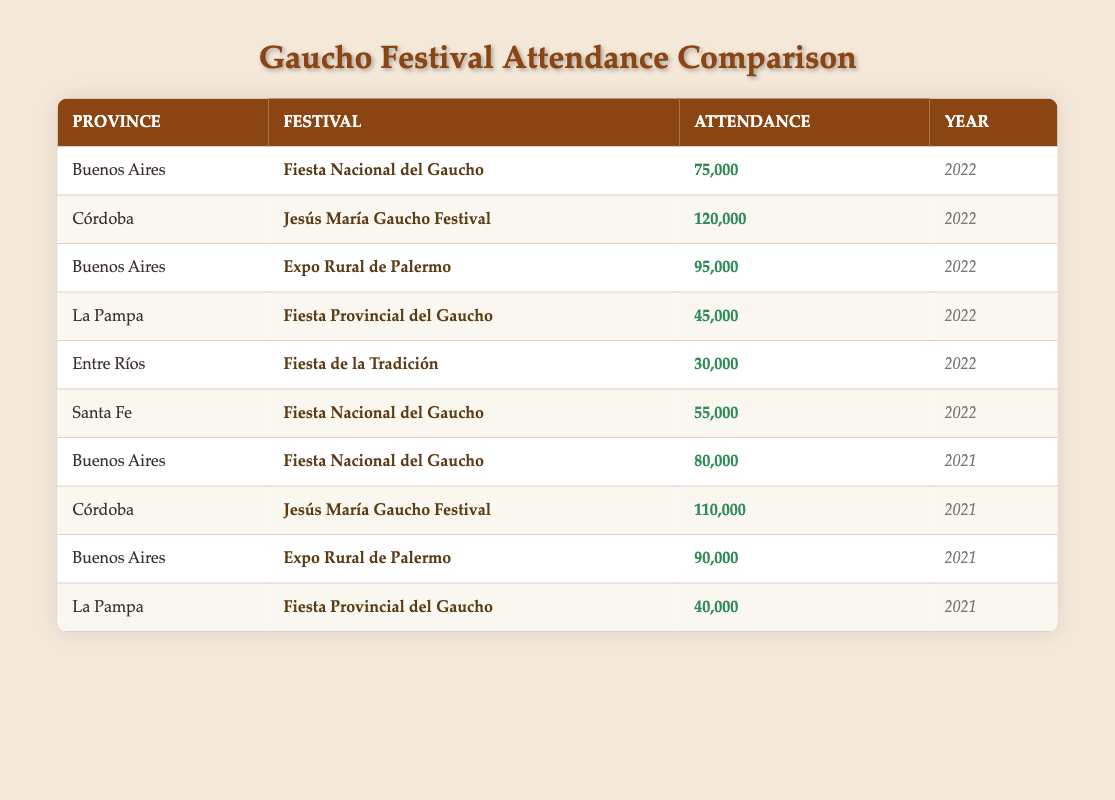What was the highest attendance at a gaucho festival in 2022? In the table, I look for the highest attendance value in the year 2022. The highest attendance is 120,000, which corresponds to the Córdoba province's Jesús María Gaucho Festival.
Answer: 120,000 Which province had the lowest attendance in 2022? By reviewing the attendance data for 2022, I find that Entre Ríos had the lowest attendance at 30,000 during the Fiesta de la Tradición.
Answer: Entre Ríos What is the total attendance for Buenos Aires festivals in 2021? I look for the attendance records for Buenos Aires in 2021, which are 80,000 for the Fiesta Nacional del Gaucho and 90,000 for Expo Rural de Palermo. Summing these values gives 80,000 + 90,000 = 170,000.
Answer: 170,000 Did La Pampa have a gaucho festival attendance higher than Santa Fe in 2022? Checking the attendance of La Pampa, which was 45,000, and Santa Fe, which was 55,000, reveals that La Pampa's attendance is lower than Santa Fe's. Therefore, the answer is no.
Answer: No What was the average attendance for the Jesús María Gaucho Festival over 2021 and 2022? The attendance for the Jesús María Gaucho Festival in 2021 is 110,000, and in 2022, it is 120,000. To find the average: (110,000 + 120,000) / 2 = 230,000 / 2 = 115,000.
Answer: 115,000 How many more attendees did the Expo Rural de Palermo have compared to the Fiesta Provincial del Gaucho in 2022? The Expo Rural de Palermo had an attendance of 95,000 in 2022, while the Fiesta Provincial del Gaucho in La Pampa had 45,000. The difference is 95,000 - 45,000 = 50,000.
Answer: 50,000 Is Santa Fe's attendance in 2022 equal to or greater than La Pampa's attendance in the same year? Santa Fe's attendance for 2022 is 55,000 and La Pampa's is 45,000. Since 55,000 is greater than 45,000, the answer is yes.
Answer: Yes What percentage of the total gaucho festival attendance in 2022 does Entre Ríos represent? The total attendance in 2022 across all provinces is 75,000 (Buenos Aires) + 120,000 (Córdoba) + 95,000 (Buenos Aires) + 45,000 (La Pampa) + 30,000 (Entre Ríos) + 55,000 (Santa Fe) = 420,000. To find Entre Ríos' percentage: (30,000 / 420,000) * 100 ≈ 7.14%.
Answer: 7.14% 